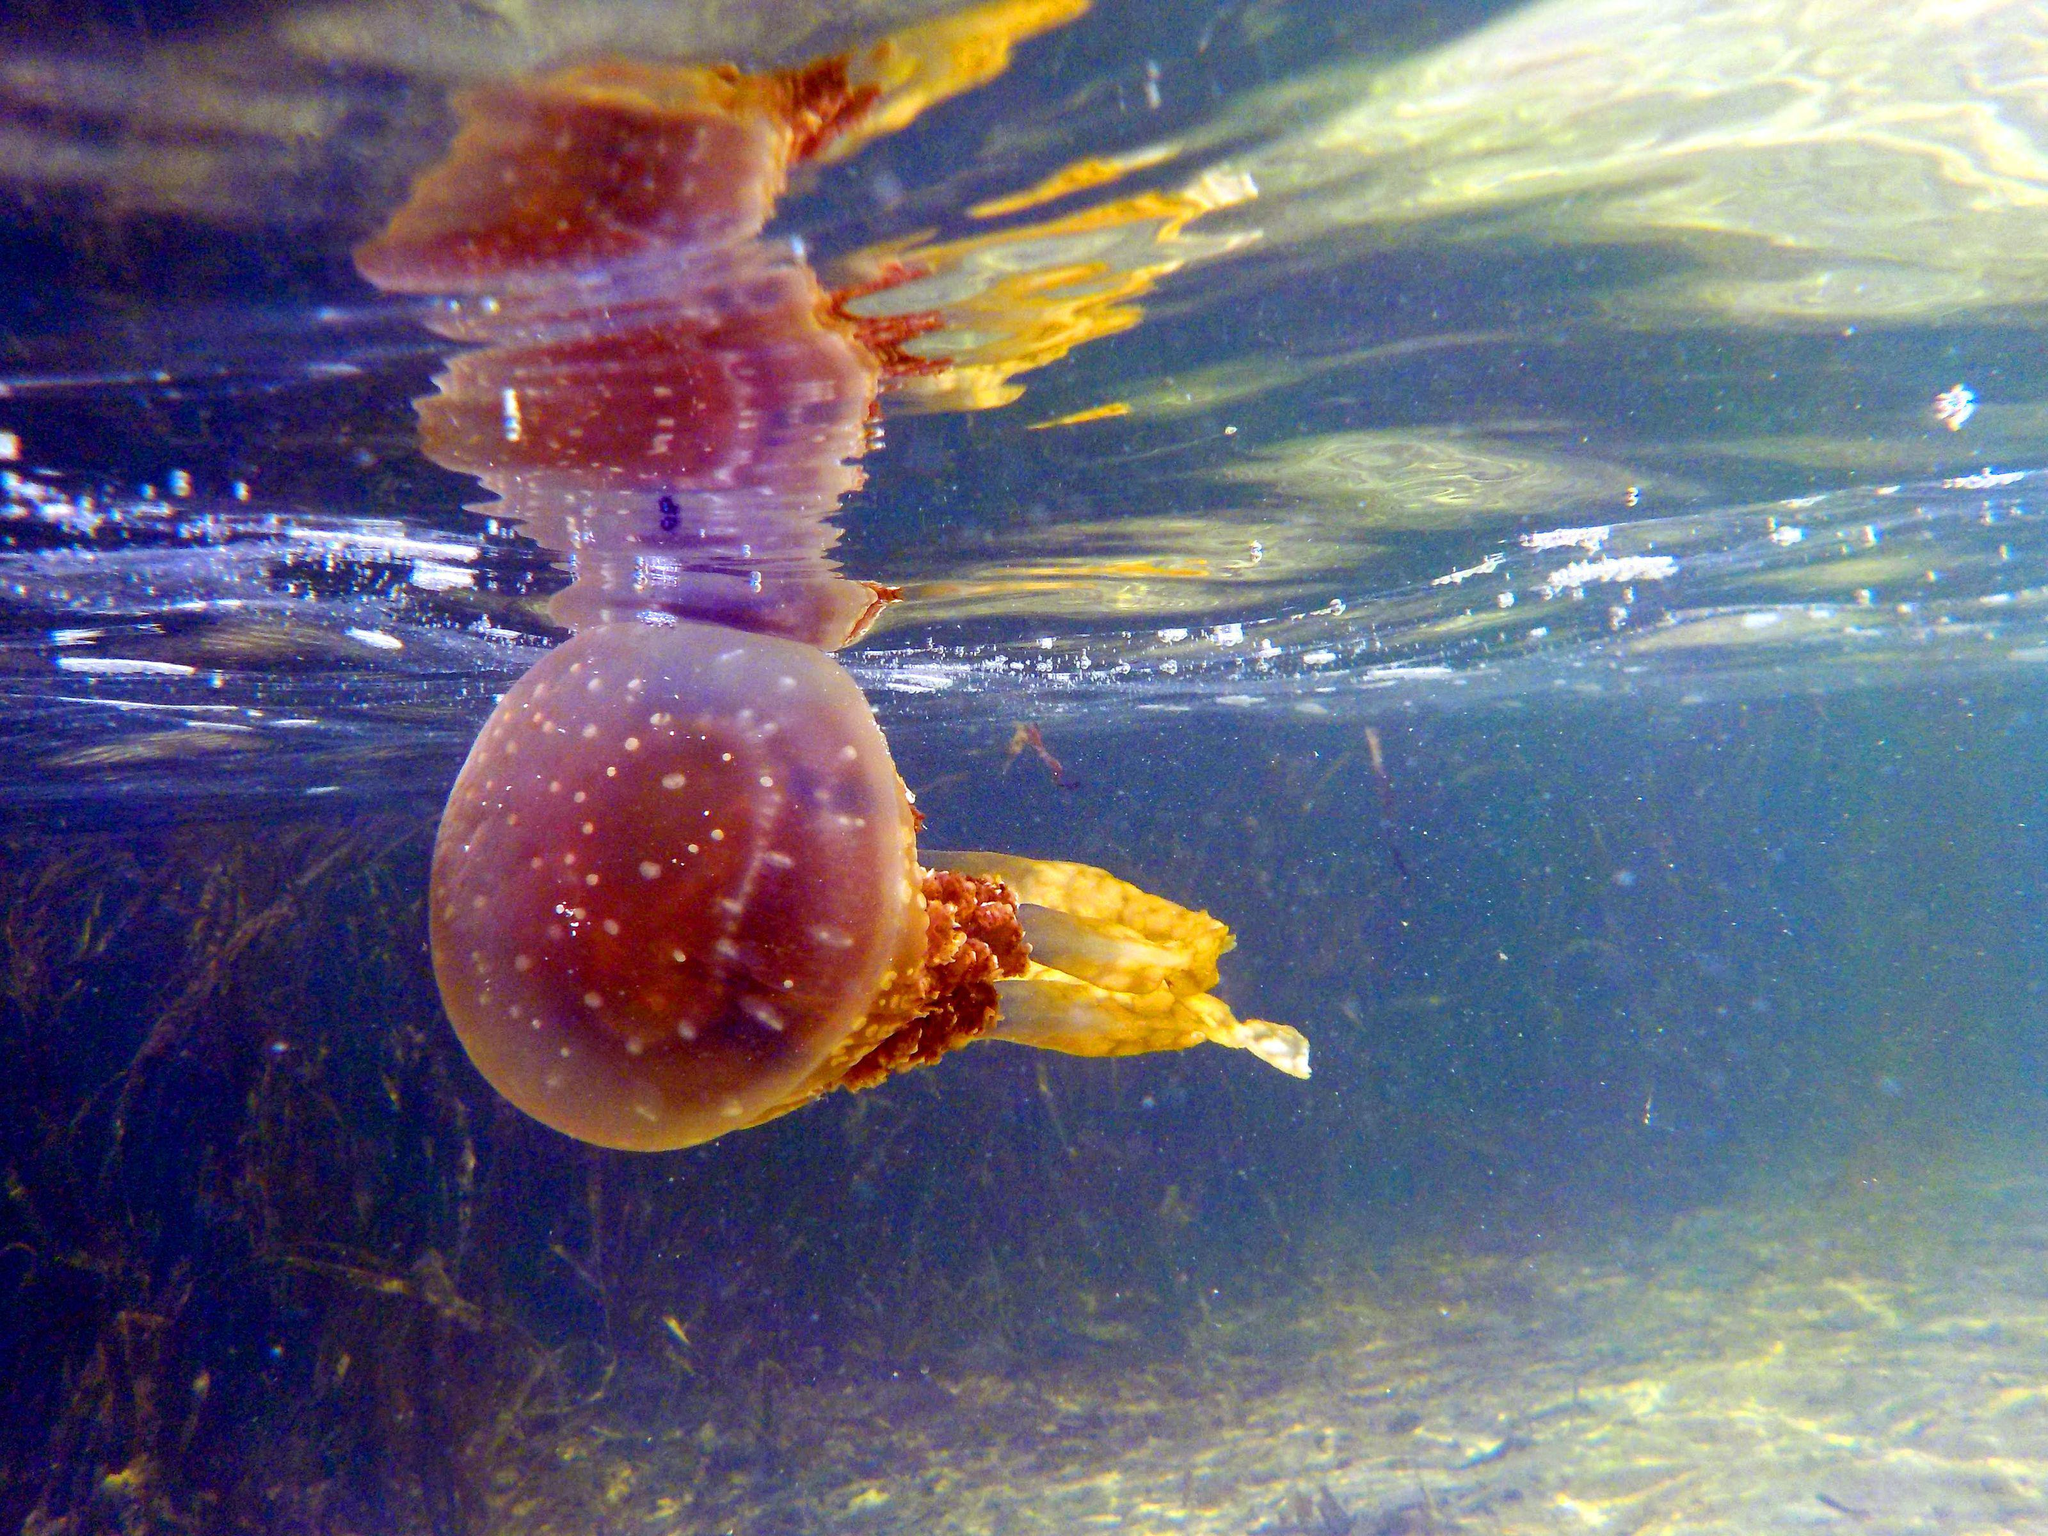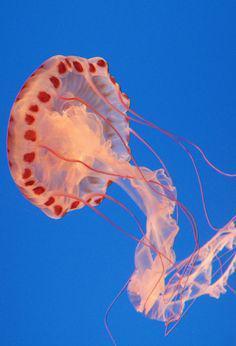The first image is the image on the left, the second image is the image on the right. Evaluate the accuracy of this statement regarding the images: "The left image contains a single jellyfish, which has an upright mushroom-shaped cap that trails stringy and ruffly tentacles beneath it.". Is it true? Answer yes or no. No. 